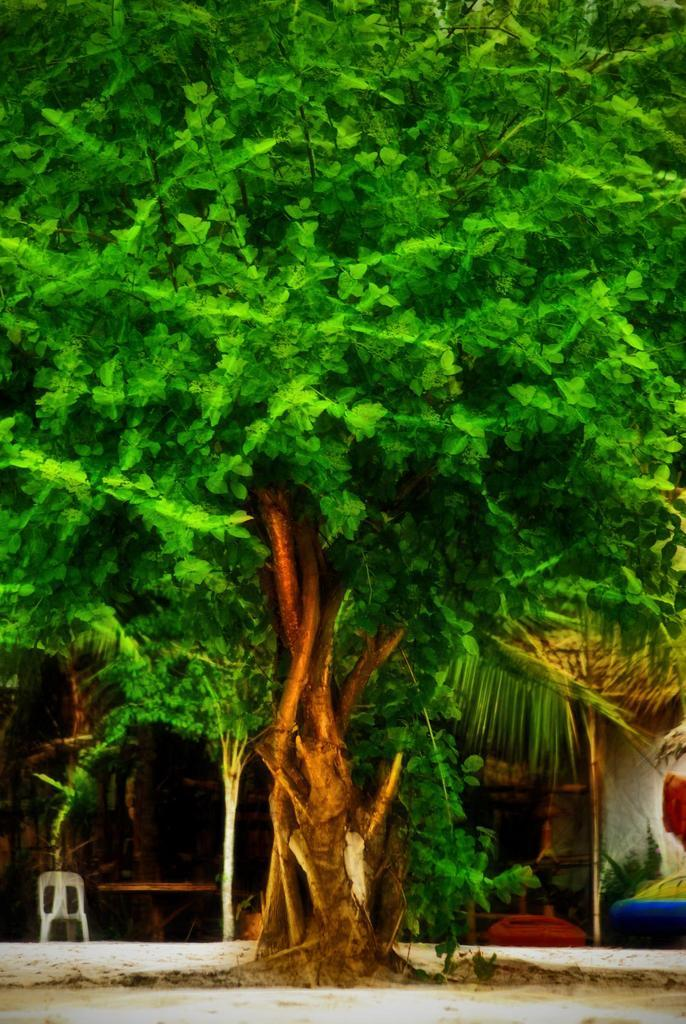What type of plant is visible on the ground in the image? There is a tree on the ground in the image. What structure can be seen on the right side of the image? There is a wall on the right side of the image. What type of furniture is on the left side of the image? There is a chair on the left side of the image. Can you see any toes on the tree in the image? There are no toes present on the tree in the image, as it is a plant and not a living being. Is there a leg visible on the wall in the image? There is no leg present on the wall in the image; it is a structure and not a living being. 